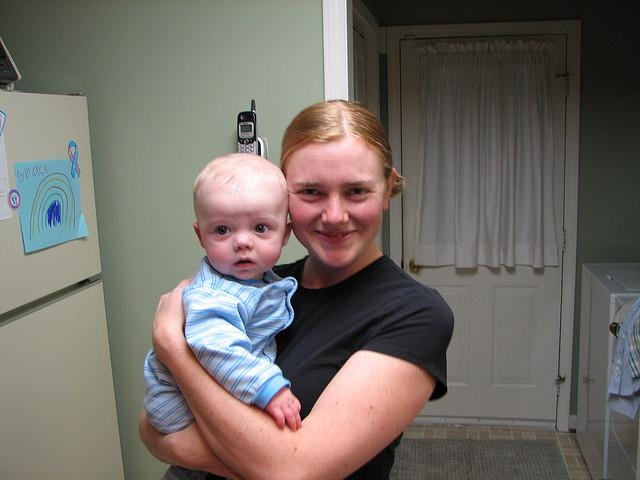Why is she smiling? happy 